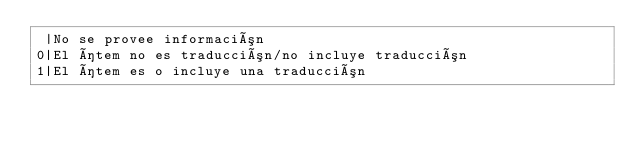Convert code to text. <code><loc_0><loc_0><loc_500><loc_500><_SQL_> |No se provee información
0|El ítem no es traducción/no incluye traducción  
1|El ítem es o incluye una traducción
</code> 